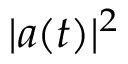Convert formula to latex. <formula><loc_0><loc_0><loc_500><loc_500>| a ( t ) | ^ { 2 }</formula> 